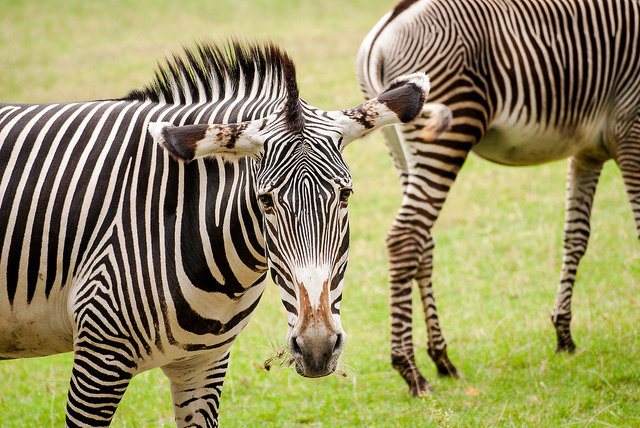Can you tell me more about the environment where these zebras live? Zebras typically inhabit grasslands, savannas, and occasionally bushy areas where they can find plentiful grass to eat. This image, with its background of ample greenery, suggests a habitat rich in foliage, which is ideal for zebras as it offers both food and some coverage against predators. The tranquil setting might indicate a lack of immediate danger, allowing the animals to be relatively relaxed. 